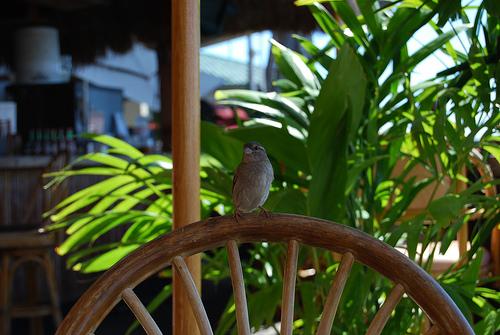Is there a bird?
Answer briefly. Yes. Where is the bird resting in the photo?
Answer briefly. Chair. Is that a wheel?
Be succinct. Yes. 